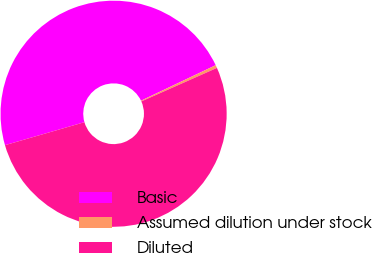<chart> <loc_0><loc_0><loc_500><loc_500><pie_chart><fcel>Basic<fcel>Assumed dilution under stock<fcel>Diluted<nl><fcel>47.42%<fcel>0.42%<fcel>52.16%<nl></chart> 